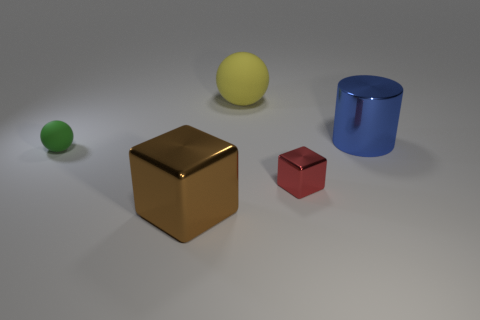Subtract all yellow spheres. Subtract all yellow blocks. How many spheres are left? 1 Add 5 red shiny cubes. How many objects exist? 10 Subtract all cubes. How many objects are left? 3 Add 3 small shiny blocks. How many small shiny blocks are left? 4 Add 2 brown cubes. How many brown cubes exist? 3 Subtract 0 blue spheres. How many objects are left? 5 Subtract all yellow objects. Subtract all large rubber objects. How many objects are left? 3 